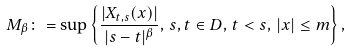Convert formula to latex. <formula><loc_0><loc_0><loc_500><loc_500>M _ { \beta } \colon = \sup \left \{ \frac { | X _ { t , s } ( x ) | } { | s - t | ^ { \beta } } , \, s , t \in D , \, t < s , \, | x | \leq m \right \} ,</formula> 